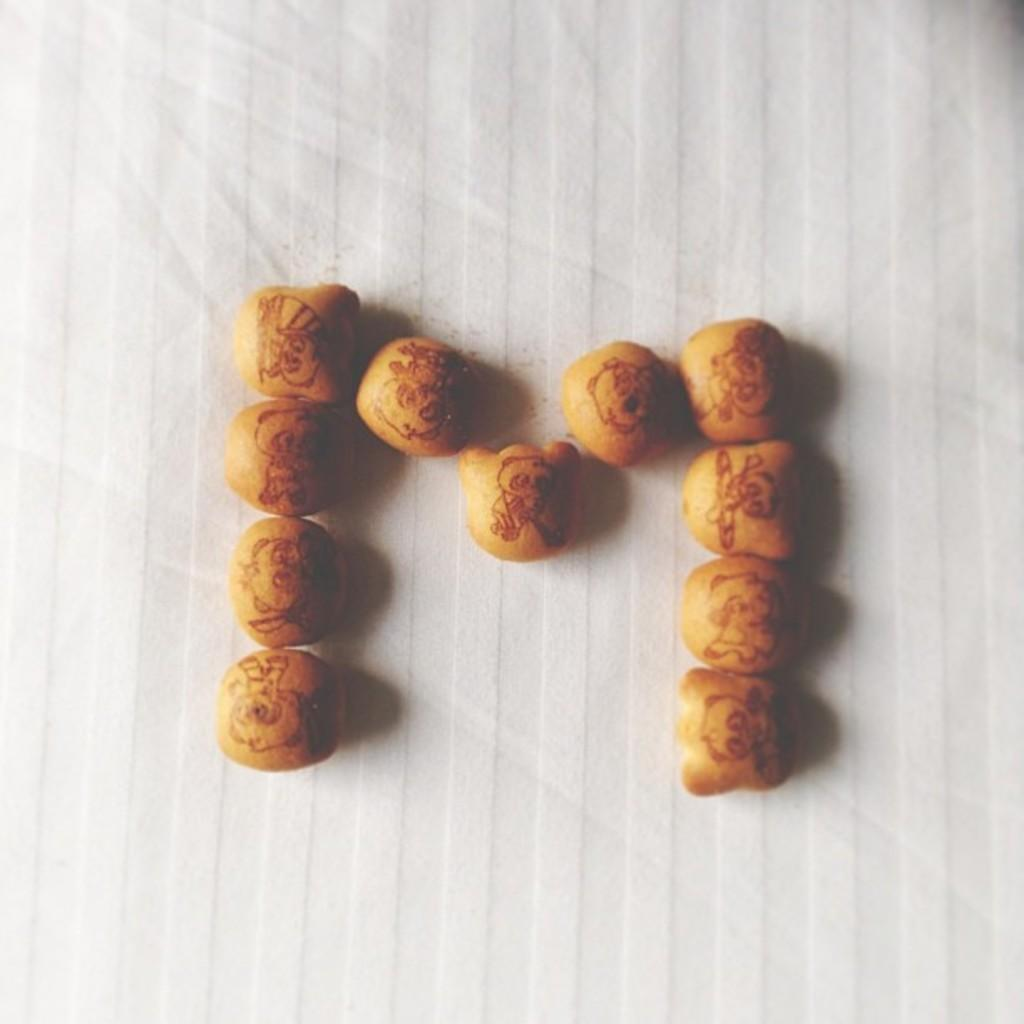What type of fruit is present in the image? There are many apples in the image. What design is featured on the apples? The apples have a design of a bear. Where are the apples located in the image? The apples are kept on a bed. What type of polish is applied to the bear's toe on the apple in the image? There is no polish or bear's toe present in the image; it features apples with a bear design. 